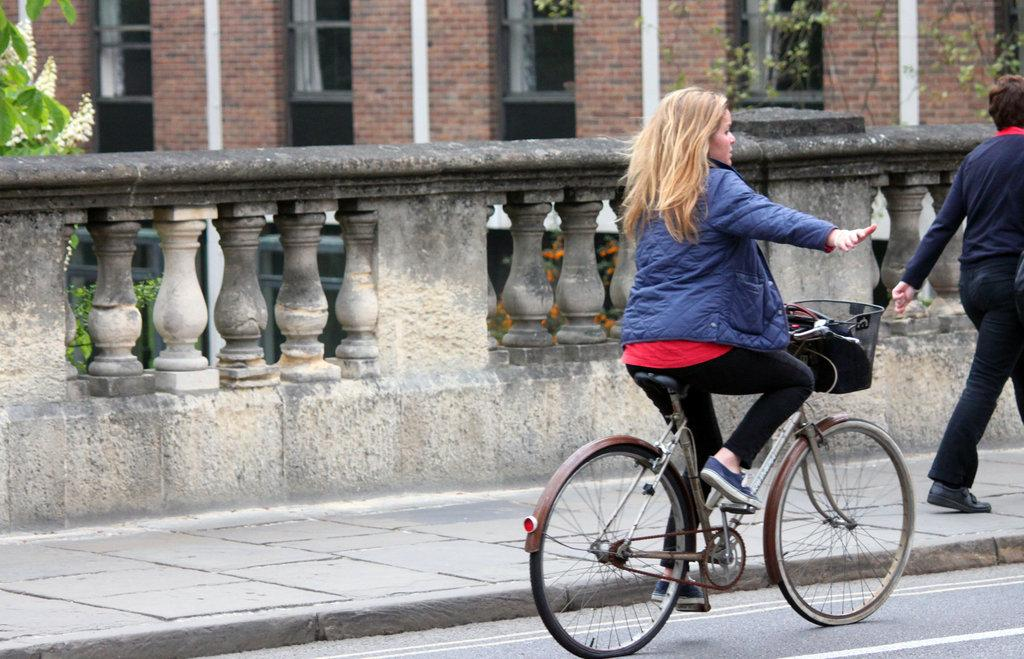Who is present in the image? There is a woman in the image. What is the woman doing in the image? The woman is on a bicycle. What can be seen in the background of the image? There is a building in the background of the image. Can you describe the setting where the woman is located? The woman is on a bicycle on a road, with a building in the background. What type of fang can be seen on the bicycle in the image? There are no fangs present on the bicycle or any other part of the image. 